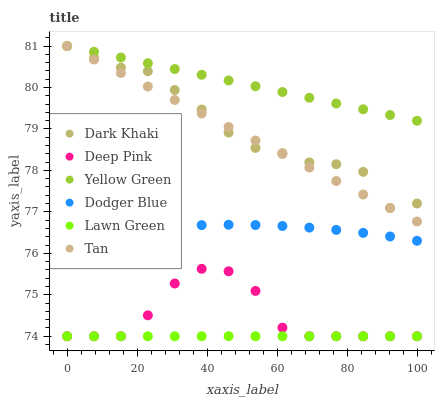Does Lawn Green have the minimum area under the curve?
Answer yes or no. Yes. Does Yellow Green have the maximum area under the curve?
Answer yes or no. Yes. Does Deep Pink have the minimum area under the curve?
Answer yes or no. No. Does Deep Pink have the maximum area under the curve?
Answer yes or no. No. Is Tan the smoothest?
Answer yes or no. Yes. Is Deep Pink the roughest?
Answer yes or no. Yes. Is Yellow Green the smoothest?
Answer yes or no. No. Is Yellow Green the roughest?
Answer yes or no. No. Does Lawn Green have the lowest value?
Answer yes or no. Yes. Does Yellow Green have the lowest value?
Answer yes or no. No. Does Tan have the highest value?
Answer yes or no. Yes. Does Deep Pink have the highest value?
Answer yes or no. No. Is Deep Pink less than Dark Khaki?
Answer yes or no. Yes. Is Yellow Green greater than Lawn Green?
Answer yes or no. Yes. Does Tan intersect Yellow Green?
Answer yes or no. Yes. Is Tan less than Yellow Green?
Answer yes or no. No. Is Tan greater than Yellow Green?
Answer yes or no. No. Does Deep Pink intersect Dark Khaki?
Answer yes or no. No. 